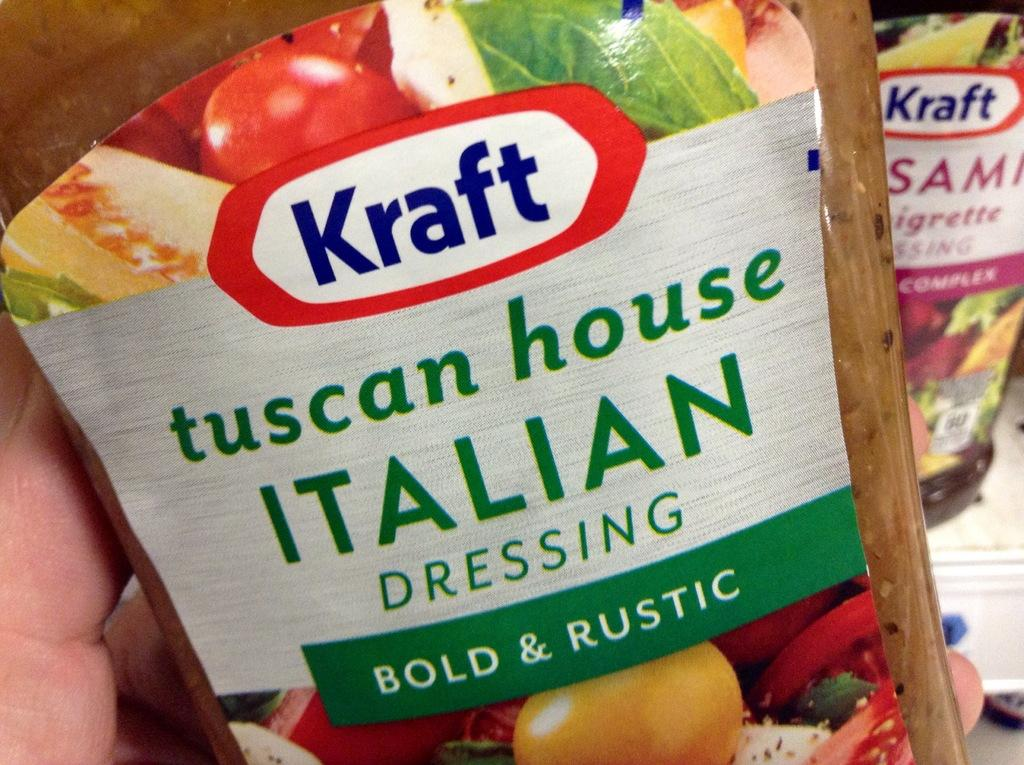What is the person's hand holding in the image? There is a person's hand holding a food bottle in the image. Can you describe the background of the image? There is another food bottle on a rack in the background of the image. What type of fear can be seen on the person's face in the image? There is no person's face visible in the image, only their hand holding a food bottle. What type of lock is securing the food bottle on the rack in the image? There is no lock visible on the food bottle on the rack in the image. 